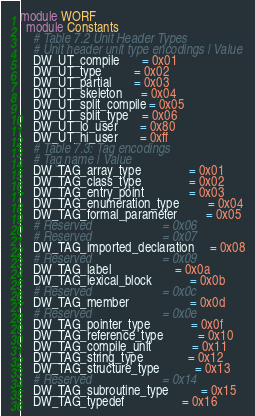Convert code to text. <code><loc_0><loc_0><loc_500><loc_500><_Ruby_>module WORF
  module Constants
    # Table 7.2 Unit Header Types
    # Unit header unit type encodings | Value
    DW_UT_compile       = 0x01
    DW_UT_type          = 0x02
    DW_UT_partial       = 0x03
    DW_UT_skeleton      = 0x04
    DW_UT_split_compile = 0x05
    DW_UT_split_type    = 0x06
    DW_UT_lo_user       = 0x80
    DW_UT_hi_user       = 0xff
    # Table 7.3: Tag encodings
    # Tag name | Value
    DW_TAG_array_type               = 0x01
    DW_TAG_class_type               = 0x02
    DW_TAG_entry_point              = 0x03
    DW_TAG_enumeration_type         = 0x04
    DW_TAG_formal_parameter         = 0x05
    # Reserved                      = 0x06
    # Reserved                      = 0x07
    DW_TAG_imported_declaration     = 0x08
    # Reserved                      = 0x09
    DW_TAG_label                    = 0x0a
    DW_TAG_lexical_block            = 0x0b
    # Reserved                      = 0x0c
    DW_TAG_member                   = 0x0d
    # Reserved                      = 0x0e
    DW_TAG_pointer_type             = 0x0f
    DW_TAG_reference_type           = 0x10
    DW_TAG_compile_unit             = 0x11
    DW_TAG_string_type              = 0x12
    DW_TAG_structure_type           = 0x13
    # Reserved                      = 0x14
    DW_TAG_subroutine_type          = 0x15
    DW_TAG_typedef                  = 0x16</code> 